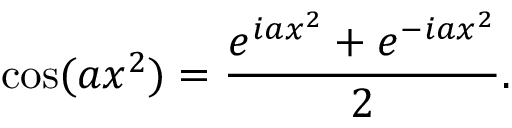Convert formula to latex. <formula><loc_0><loc_0><loc_500><loc_500>\cos ( a x ^ { 2 } ) = { \frac { e ^ { i a x ^ { 2 } } + e ^ { - i a x ^ { 2 } } } { 2 } } .</formula> 